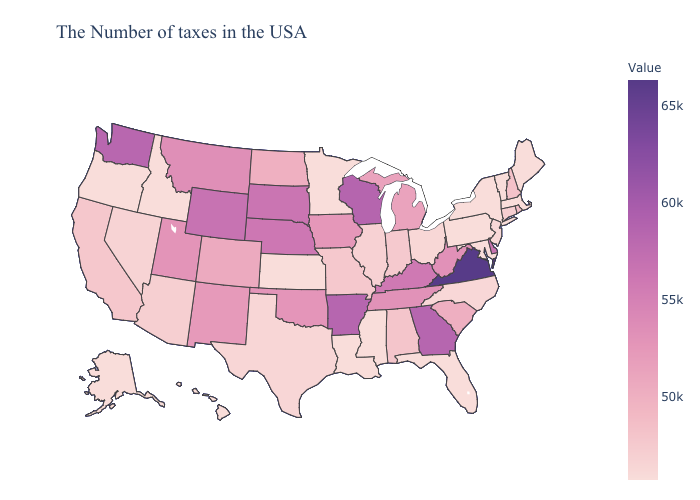Among the states that border Nebraska , does Kansas have the highest value?
Give a very brief answer. No. Does Virginia have the highest value in the USA?
Keep it brief. Yes. Does Pennsylvania have the lowest value in the Northeast?
Answer briefly. Yes. Does Alaska have a higher value than Virginia?
Be succinct. No. Which states have the lowest value in the USA?
Write a very short answer. Maine, Massachusetts, Vermont, New York, Maryland, Pennsylvania, Florida, Mississippi, Louisiana, Minnesota, Kansas, Idaho, Oregon, Alaska, Hawaii. Does Tennessee have the lowest value in the USA?
Be succinct. No. 